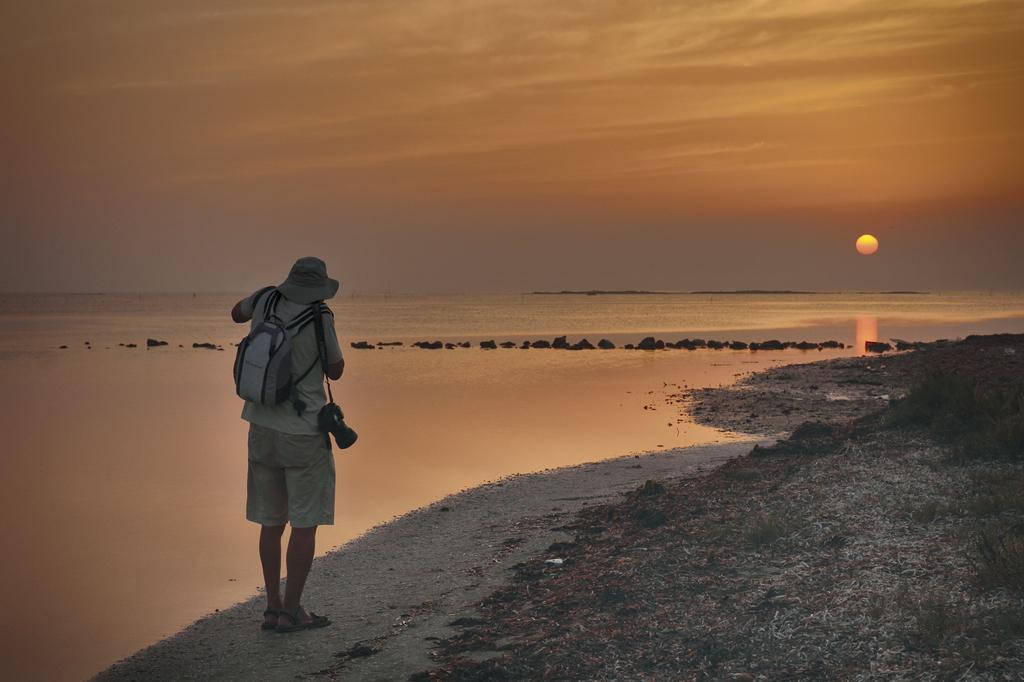Who or what is present in the image? There is a person in the image. What type of surface is visible beneath the person? There is ground visible in the image. What can be found on the ground? There are objects on the ground. What type of vegetation is present in the image? There is grass in the image. What natural feature is visible in the image? There is water visible in the image. What is visible in the background of the image? The sky is visible in the image, and clouds and the sun are present in the sky. What group of people is the person in the image trying to act like? There is no indication in the image that the person is trying to act like a group of people. 